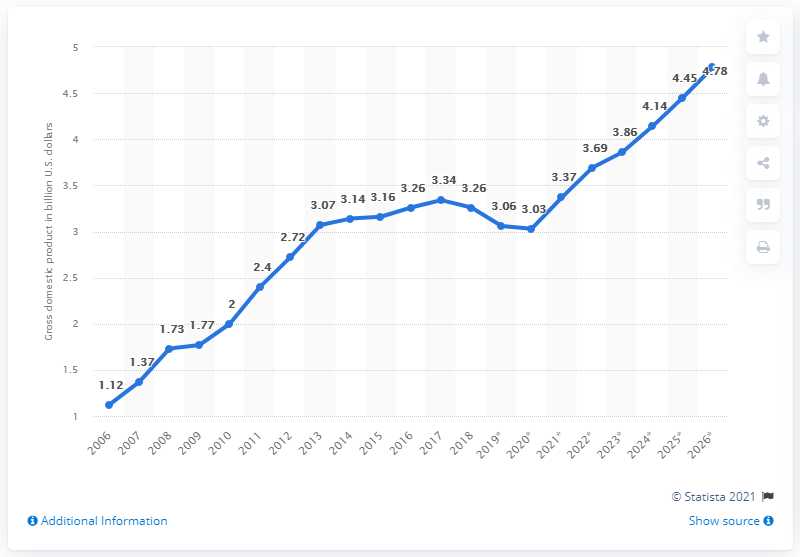Specify some key components in this picture. In 2018, the Gross Domestic Product (GDP) of Liberia was 3.26. 